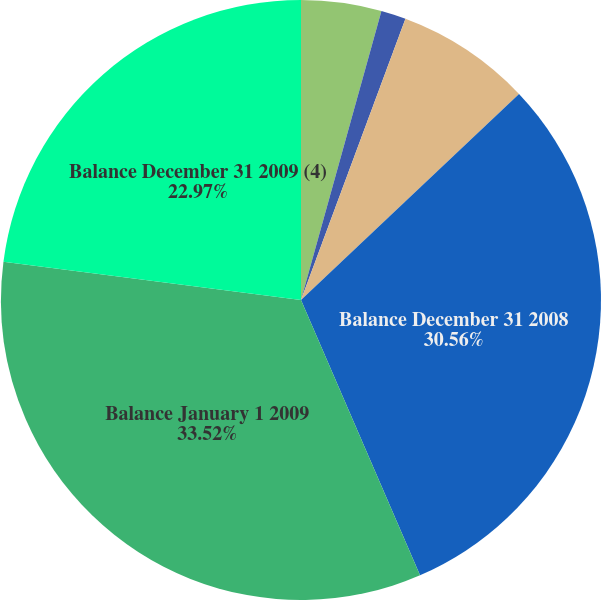<chart> <loc_0><loc_0><loc_500><loc_500><pie_chart><fcel>Balance January 1 2007<fcel>Change<fcel>Balance December 31 2007<fcel>Balance December 31 2008<fcel>Balance January 1 2009<fcel>Balance December 31 2009 (4)<nl><fcel>4.32%<fcel>1.34%<fcel>7.29%<fcel>30.56%<fcel>33.53%<fcel>22.97%<nl></chart> 